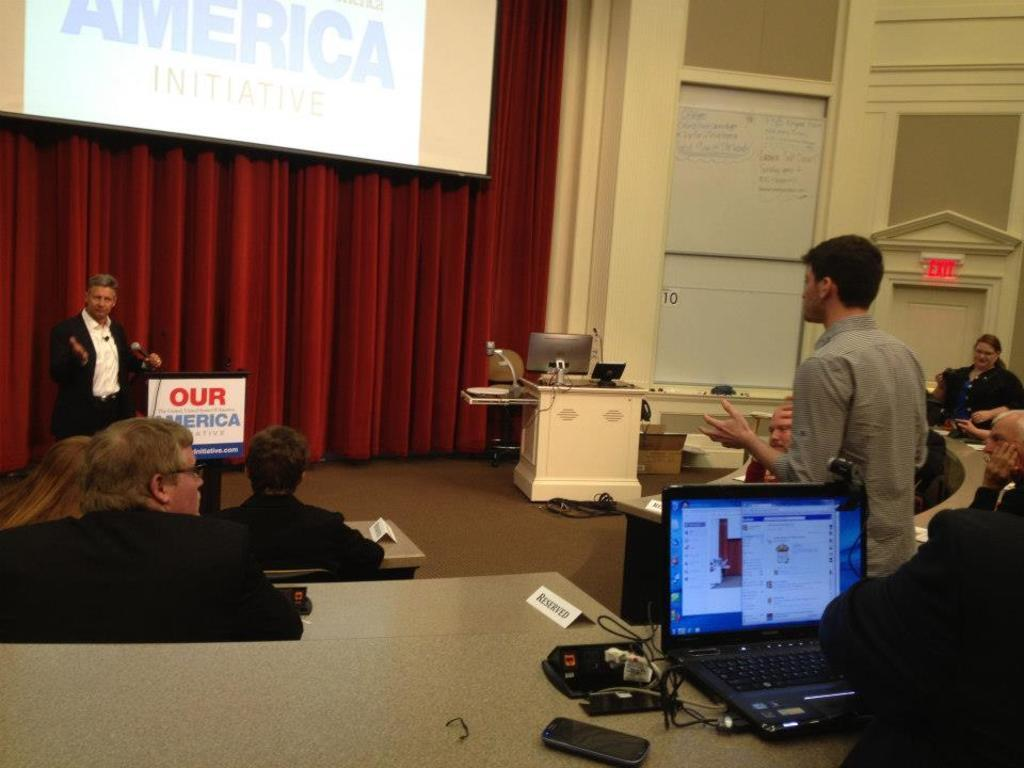<image>
Relay a brief, clear account of the picture shown. A man speaks next to an Our America sign 